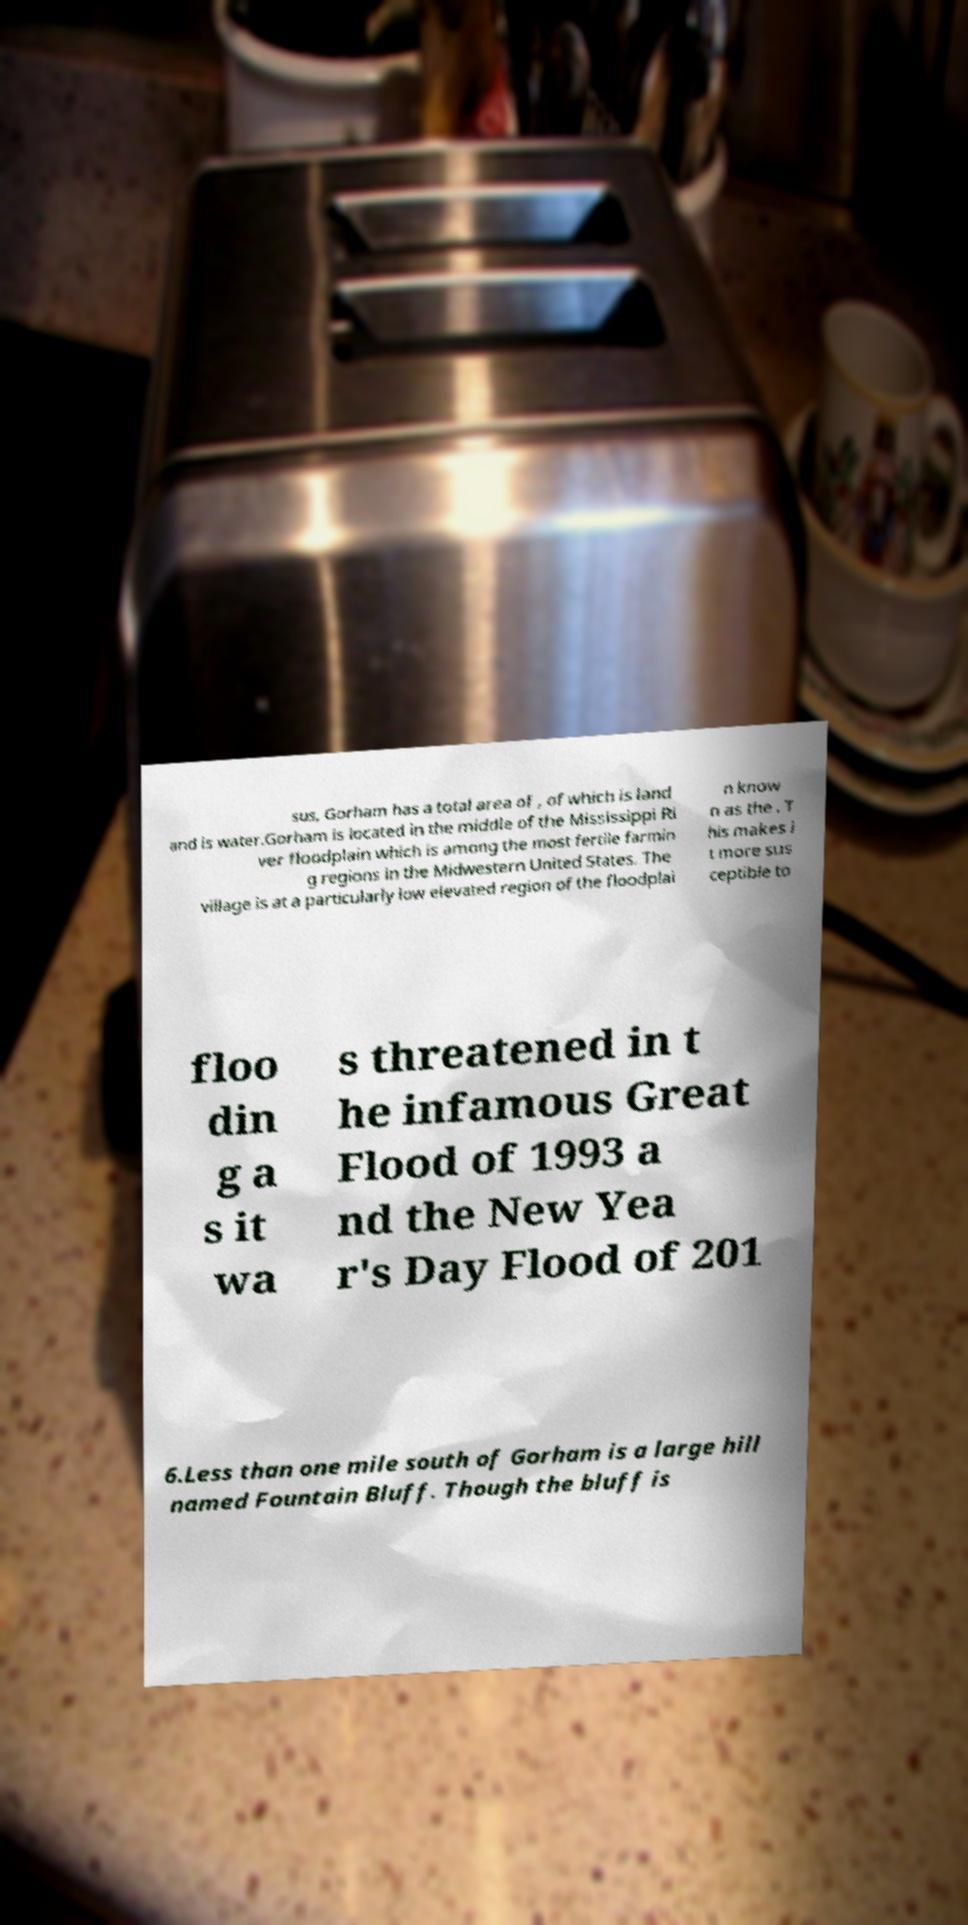What messages or text are displayed in this image? I need them in a readable, typed format. sus, Gorham has a total area of , of which is land and is water.Gorham is located in the middle of the Mississippi Ri ver floodplain which is among the most fertile farmin g regions in the Midwestern United States. The village is at a particularly low elevated region of the floodplai n know n as the . T his makes i t more sus ceptible to floo din g a s it wa s threatened in t he infamous Great Flood of 1993 a nd the New Yea r's Day Flood of 201 6.Less than one mile south of Gorham is a large hill named Fountain Bluff. Though the bluff is 